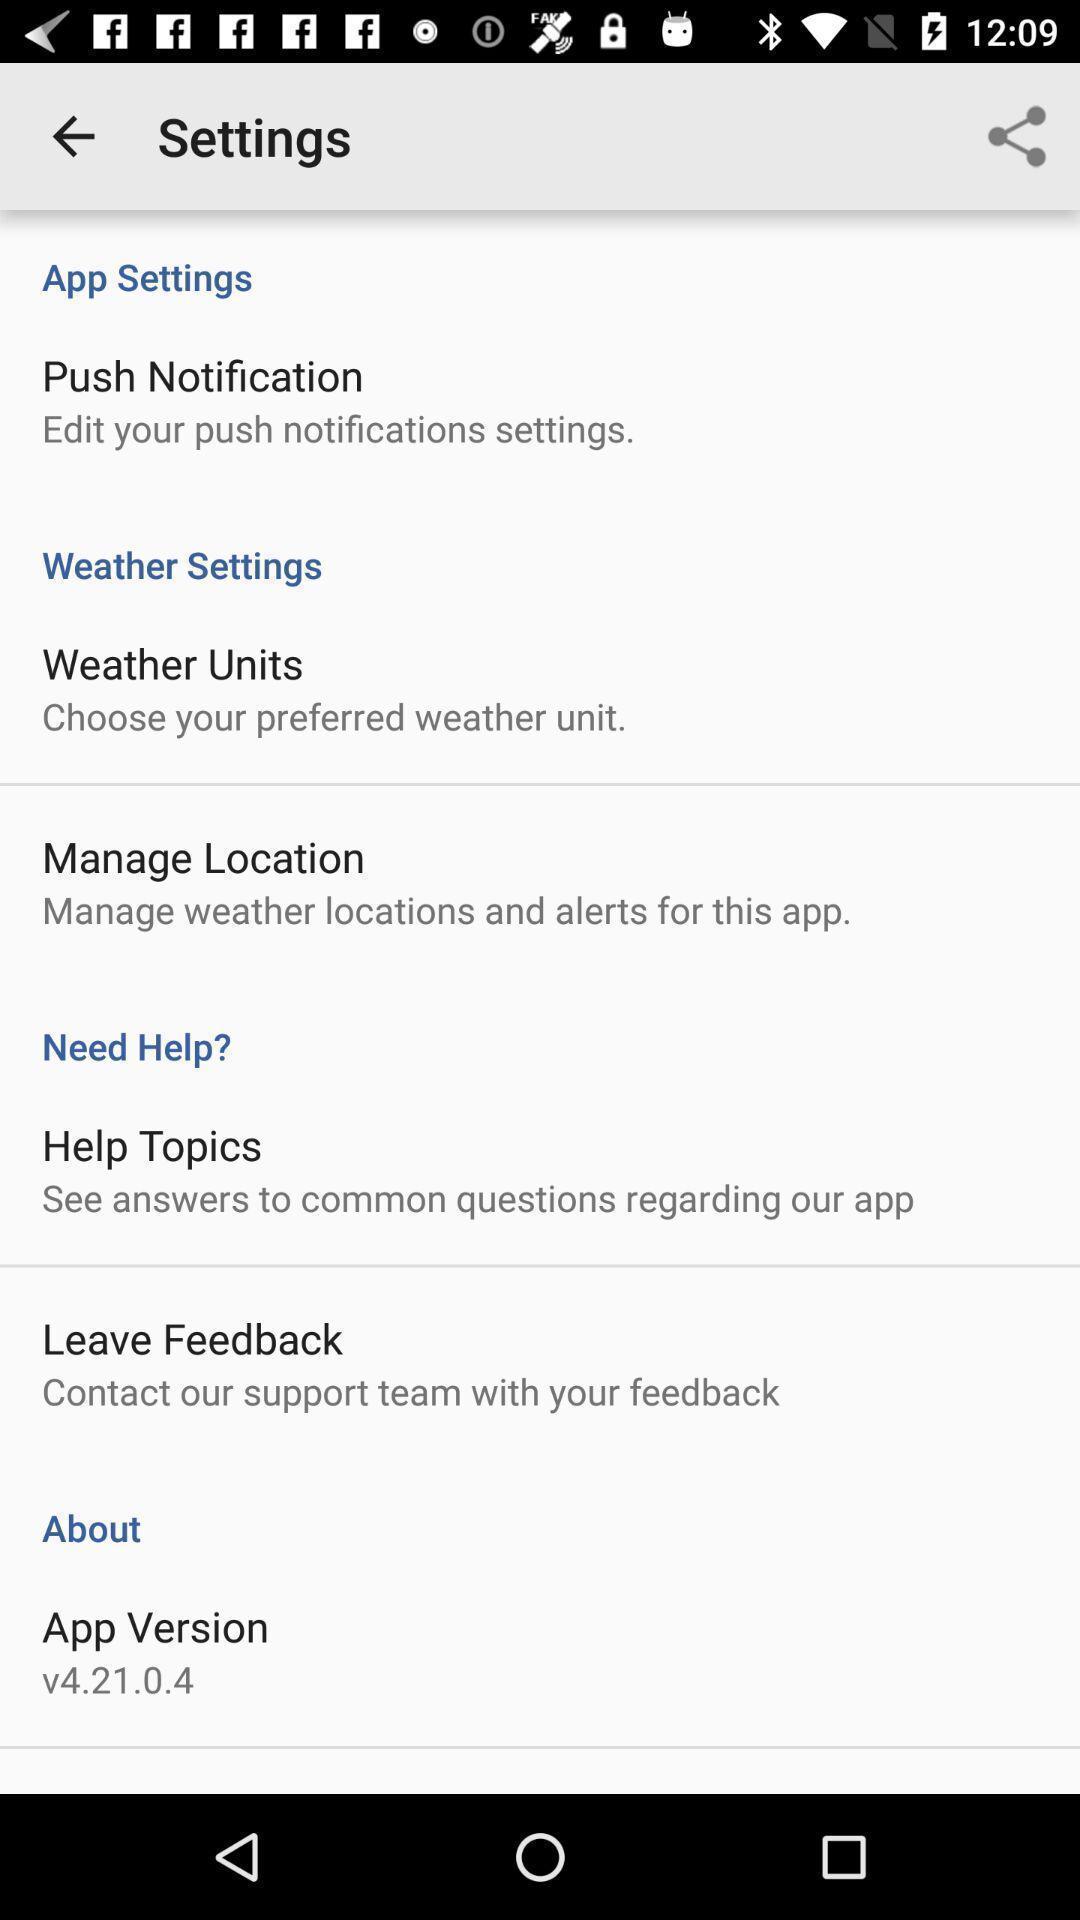Summarize the main components in this picture. Settings page with various other options. 